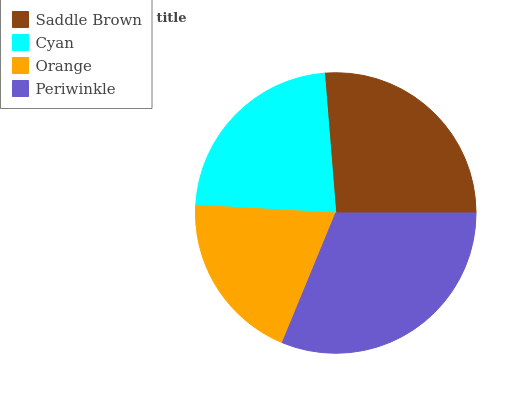Is Orange the minimum?
Answer yes or no. Yes. Is Periwinkle the maximum?
Answer yes or no. Yes. Is Cyan the minimum?
Answer yes or no. No. Is Cyan the maximum?
Answer yes or no. No. Is Saddle Brown greater than Cyan?
Answer yes or no. Yes. Is Cyan less than Saddle Brown?
Answer yes or no. Yes. Is Cyan greater than Saddle Brown?
Answer yes or no. No. Is Saddle Brown less than Cyan?
Answer yes or no. No. Is Saddle Brown the high median?
Answer yes or no. Yes. Is Cyan the low median?
Answer yes or no. Yes. Is Cyan the high median?
Answer yes or no. No. Is Saddle Brown the low median?
Answer yes or no. No. 